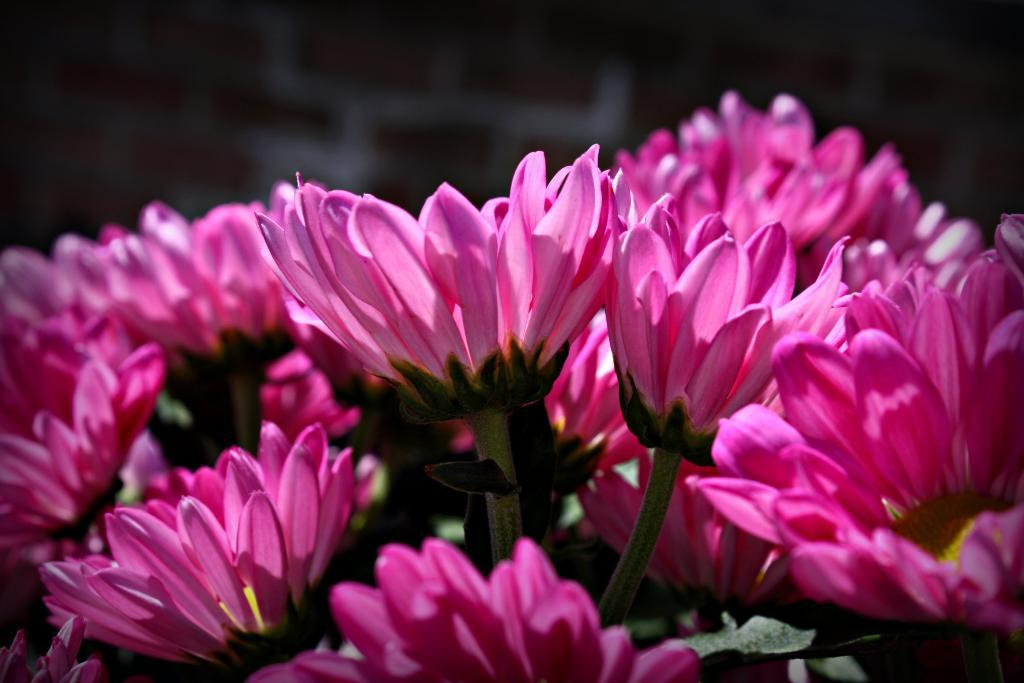What type of flowers can be seen in the image? There are pink flowers in the image. How would you describe the background of the image? The background of the image is dark. What type of punishment is being administered to the wrist in the image? There is no wrist or punishment present in the image; it only features pink flowers and a dark background. 